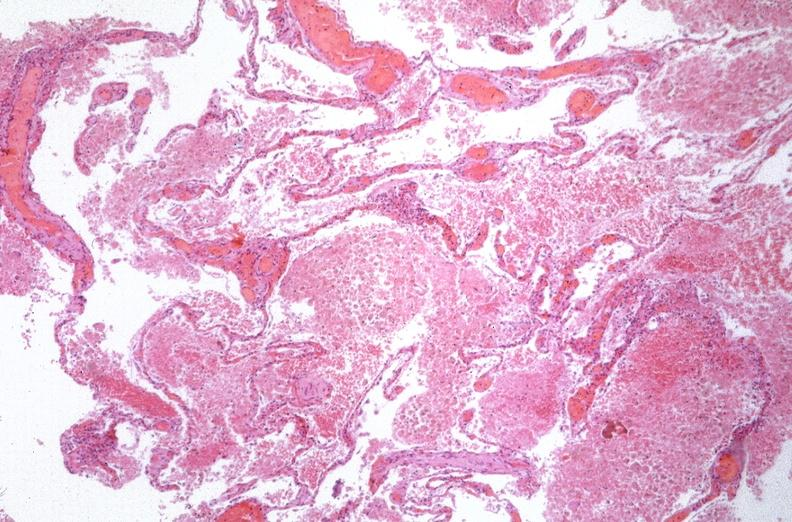s respiratory present?
Answer the question using a single word or phrase. Yes 